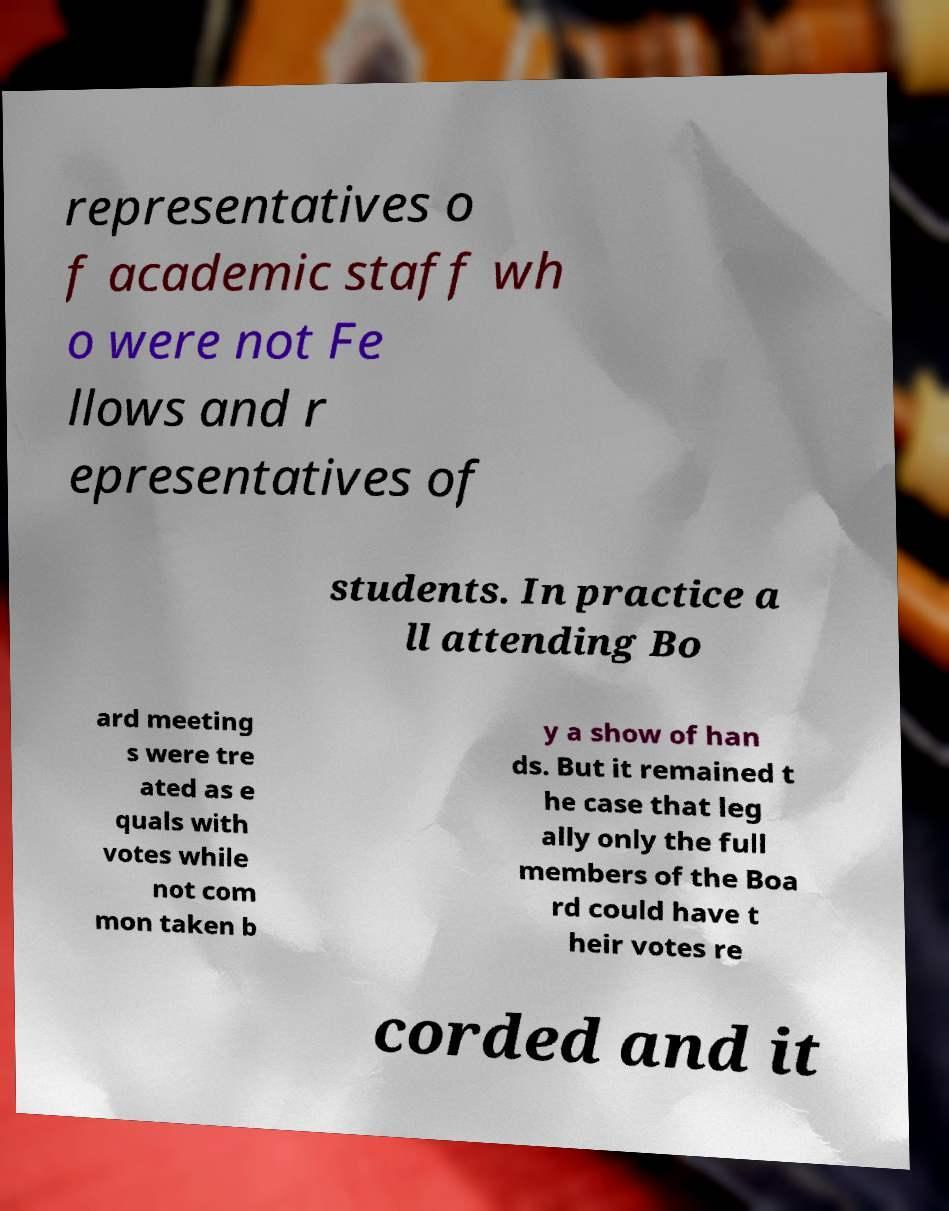I need the written content from this picture converted into text. Can you do that? representatives o f academic staff wh o were not Fe llows and r epresentatives of students. In practice a ll attending Bo ard meeting s were tre ated as e quals with votes while not com mon taken b y a show of han ds. But it remained t he case that leg ally only the full members of the Boa rd could have t heir votes re corded and it 